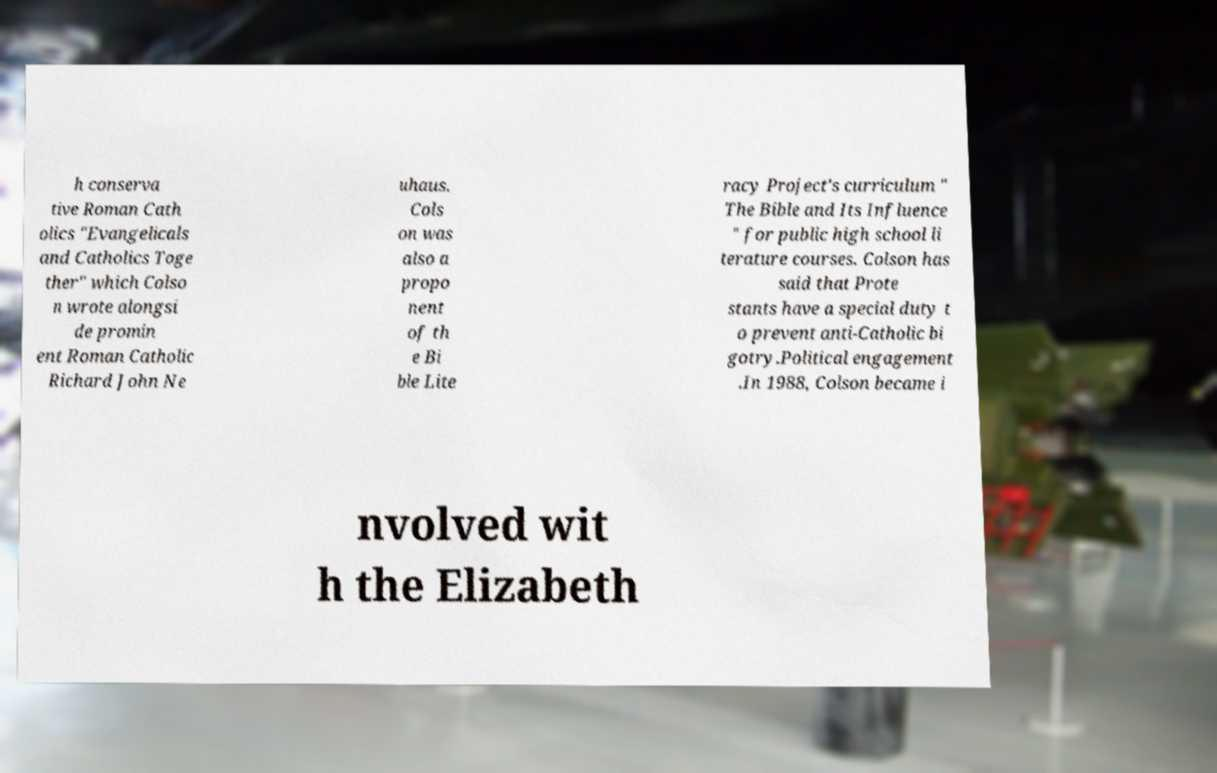Can you accurately transcribe the text from the provided image for me? h conserva tive Roman Cath olics "Evangelicals and Catholics Toge ther" which Colso n wrote alongsi de promin ent Roman Catholic Richard John Ne uhaus. Cols on was also a propo nent of th e Bi ble Lite racy Project's curriculum " The Bible and Its Influence " for public high school li terature courses. Colson has said that Prote stants have a special duty t o prevent anti-Catholic bi gotry.Political engagement .In 1988, Colson became i nvolved wit h the Elizabeth 